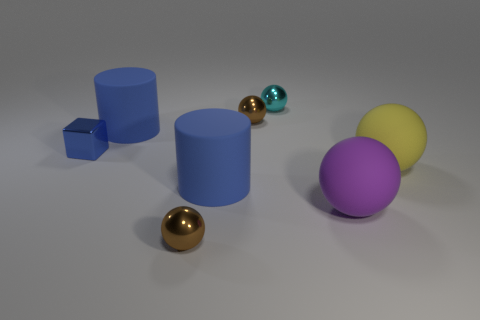There is a cyan sphere that is the same material as the small blue thing; what size is it?
Your answer should be very brief. Small. There is another rubber object that is the same shape as the yellow matte thing; what is its size?
Offer a terse response. Large. Are there any matte blocks?
Your response must be concise. No. How many objects are either spheres on the left side of the big purple sphere or tiny blue objects?
Your response must be concise. 4. There is a cyan ball that is the same size as the blue metallic cube; what is it made of?
Ensure brevity in your answer.  Metal. What is the color of the rubber object on the left side of the blue matte cylinder in front of the blue cube?
Your response must be concise. Blue. How many matte things are behind the large yellow rubber thing?
Offer a very short reply. 1. The small block is what color?
Your response must be concise. Blue. What number of big things are either green spheres or cylinders?
Make the answer very short. 2. Do the tiny shiny block that is behind the yellow thing and the large rubber ball behind the big purple matte ball have the same color?
Your answer should be very brief. No. 